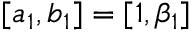<formula> <loc_0><loc_0><loc_500><loc_500>[ a _ { 1 } , b _ { 1 } ] = [ 1 , \beta _ { 1 } ]</formula> 